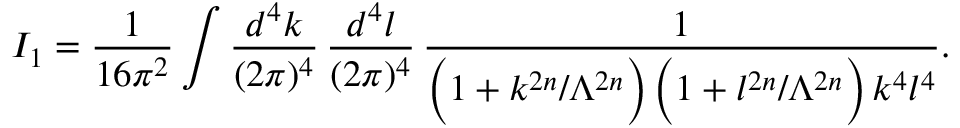<formula> <loc_0><loc_0><loc_500><loc_500>I _ { 1 } = \frac { 1 } { 1 6 \pi ^ { 2 } } \int \frac { d ^ { 4 } k } { ( 2 \pi ) ^ { 4 } } \, \frac { d ^ { 4 } l } { ( 2 \pi ) ^ { 4 } } \, \frac { 1 } { \left ( 1 + k ^ { 2 n } / \Lambda ^ { 2 n } \right ) \, \left ( 1 + l ^ { 2 n } / \Lambda ^ { 2 n } \right ) \, k ^ { 4 } l ^ { 4 } } .</formula> 